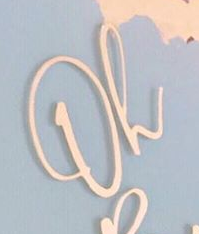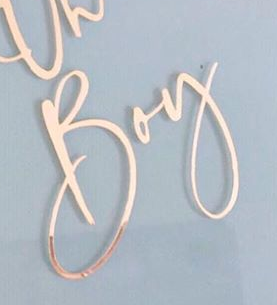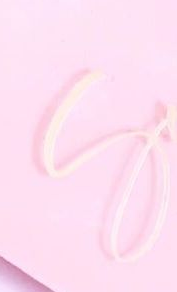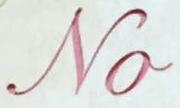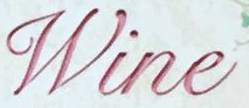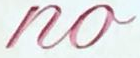What words are shown in these images in order, separated by a semicolon? Oh; Boy; S; No; Wine; no 